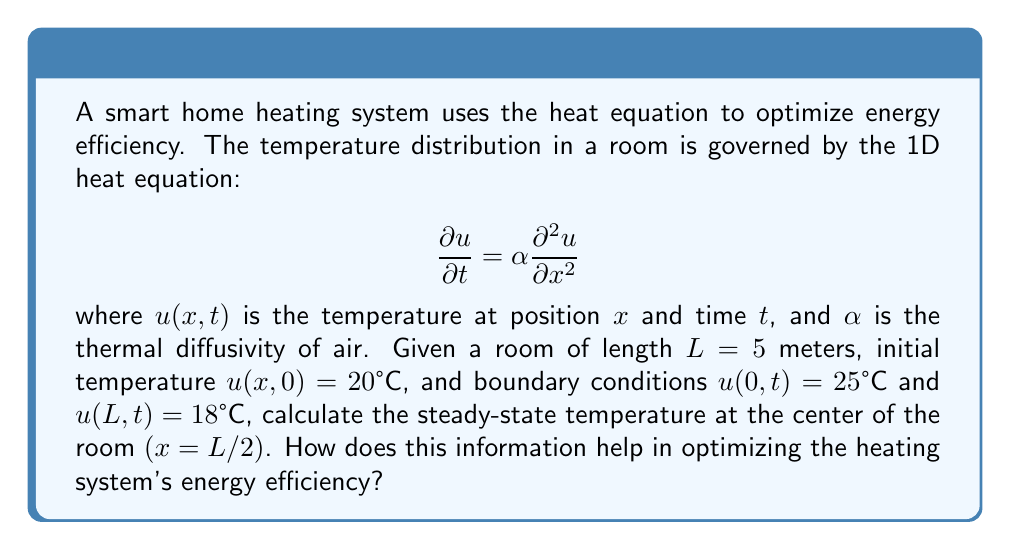Can you solve this math problem? To solve this problem, we need to follow these steps:

1) For the steady-state solution, the temperature doesn't change with time, so $\frac{\partial u}{\partial t} = 0$. The heat equation reduces to:

   $$0 = \alpha \frac{\partial^2 u}{\partial x^2}$$

2) Integrating twice with respect to $x$:

   $$u(x) = Ax + B$$

   where $A$ and $B$ are constants to be determined.

3) Apply the boundary conditions:
   At $x = 0$: $u(0) = 25°C = B$
   At $x = L = 5$: $u(5) = 18°C = 5A + 25$

4) Solve for $A$:
   $$18 = 5A + 25$$
   $$A = -\frac{7}{5} = -1.4$$

5) The steady-state temperature distribution is:
   $$u(x) = -1.4x + 25$$

6) At the center of the room $(x = L/2 = 2.5)$:
   $$u(2.5) = -1.4(2.5) + 25 = 21.5°C$$

This information helps optimize energy efficiency by:
a) Identifying temperature gradients in the room.
b) Allowing for precise temperature control at specific points.
c) Enabling the system to maintain desired temperatures with minimal energy input.
d) Facilitating the design of optimal heating/cooling strategies based on room geometry and boundary conditions.
Answer: 21.5°C 